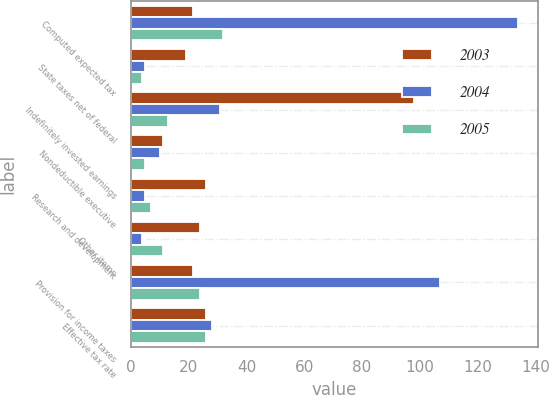Convert chart. <chart><loc_0><loc_0><loc_500><loc_500><stacked_bar_chart><ecel><fcel>Computed expected tax<fcel>State taxes net of federal<fcel>Indefinitely invested earnings<fcel>Nondeductible executive<fcel>Research and development<fcel>Other items<fcel>Provision for income taxes<fcel>Effective tax rate<nl><fcel>2003<fcel>21.5<fcel>19<fcel>98<fcel>11<fcel>26<fcel>24<fcel>21.5<fcel>26<nl><fcel>2004<fcel>134<fcel>5<fcel>31<fcel>10<fcel>5<fcel>4<fcel>107<fcel>28<nl><fcel>2005<fcel>32<fcel>4<fcel>13<fcel>5<fcel>7<fcel>11<fcel>24<fcel>26<nl></chart> 